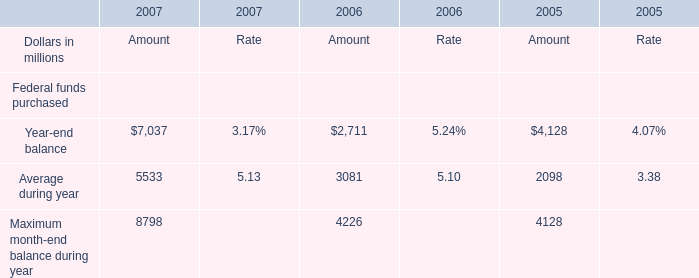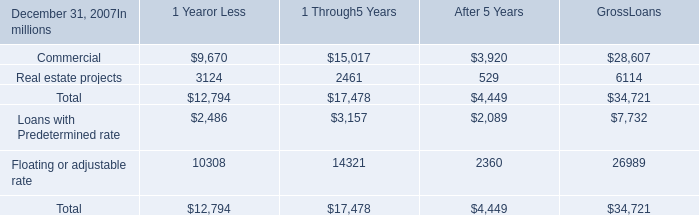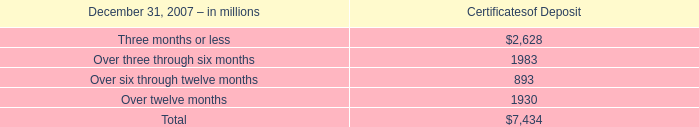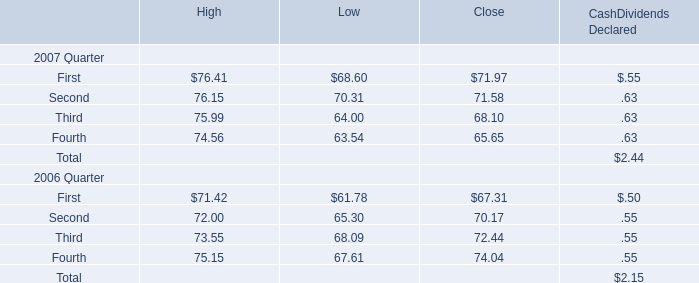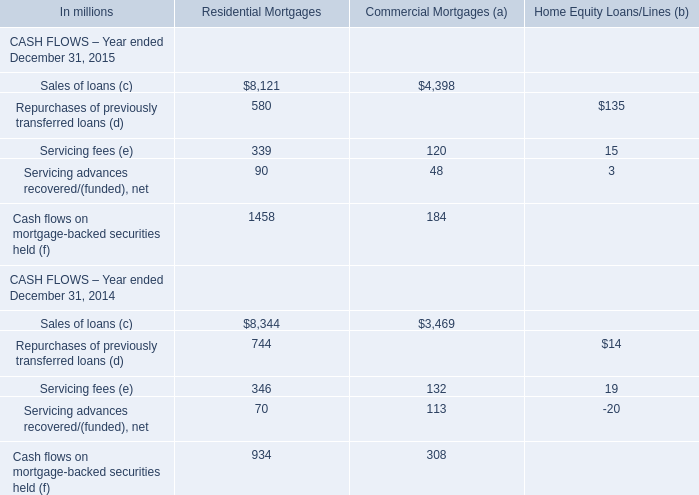What is the lowest value of Loans with Predetermined rate as As the chart 1 shows? (in million) 
Answer: 2089. 